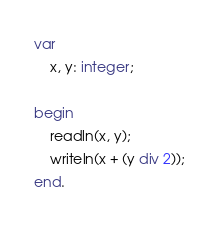<code> <loc_0><loc_0><loc_500><loc_500><_Pascal_>var
	x, y: integer;
	
begin
	readln(x, y);
	writeln(x + (y div 2));
end.</code> 